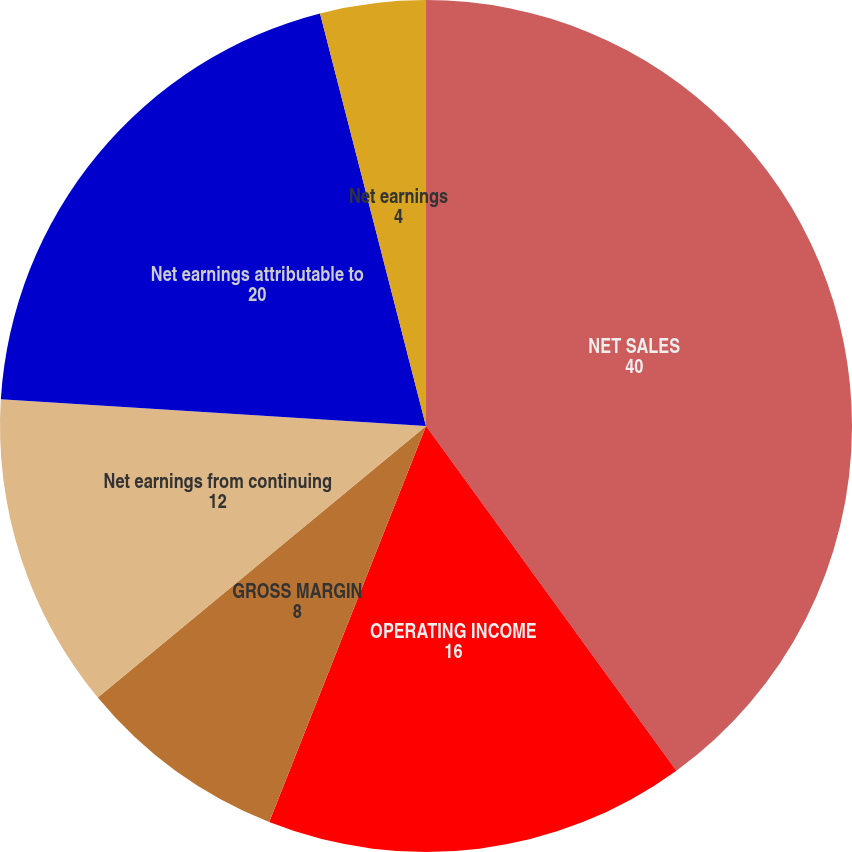Convert chart. <chart><loc_0><loc_0><loc_500><loc_500><pie_chart><fcel>NET SALES<fcel>OPERATING INCOME<fcel>GROSS MARGIN<fcel>Net earnings from continuing<fcel>Net earnings attributable to<fcel>Earnings from continuing<fcel>Net earnings<nl><fcel>40.0%<fcel>16.0%<fcel>8.0%<fcel>12.0%<fcel>20.0%<fcel>0.0%<fcel>4.0%<nl></chart> 